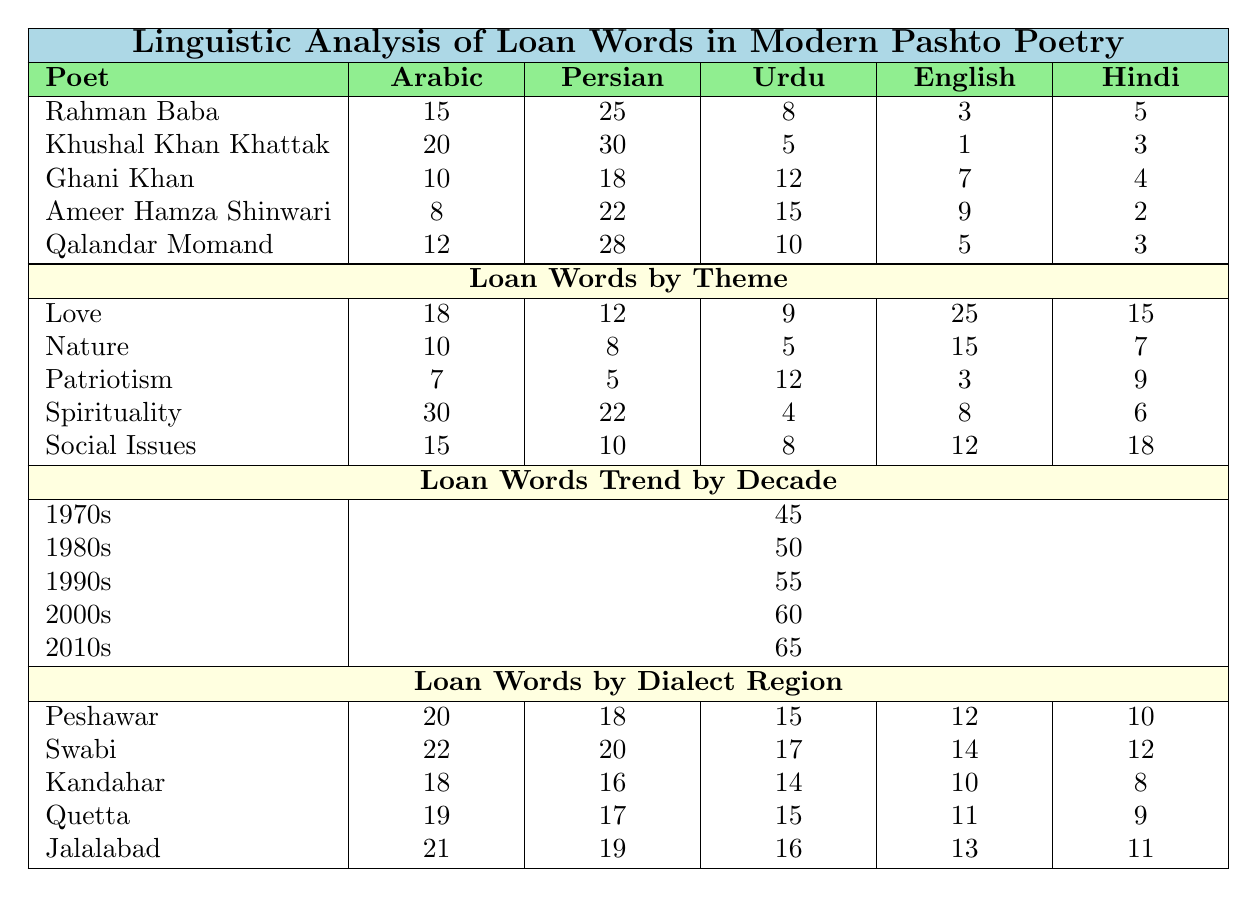What is the total number of loan words used by Ghani Khan? To find the total number of loan words used by Ghani Khan, sum up the values in his row: 10 (Arabic) + 18 (Persian) + 12 (Urdu) + 7 (English) + 4 (Hindi) = 51.
Answer: 51 Which poet has the highest use of Persian loan words? Look at the Persian column and find the maximum value: Khushal Khan Khattak has 30 Persian loan words, which is the highest among all poets listed.
Answer: Khushal Khan Khattak What is the average number of English loan words used by all poets? First, sum the English values for each poet: 3 + 1 + 7 + 9 + 5 = 25. Then divide by the number of poets, which is 5: 25/5 = 5.
Answer: 5 Do all poets use more Arabic loan words than English loan words? Compare the values for Arabic and English loan words for each poet: Rahman Baba (15 vs 3), Khushal Khan Khattak (20 vs 1), Ghani Khan (10 vs 7), Ameer Hamza Shinwari (8 vs 9), and Qalandar Momand (12 vs 5). Ameer Hamza Shinwari is the only poet that uses more English loan words (9) than Arabic (8).
Answer: No In which decade did the use of loan words peak? Look at the "Loan Words Trend by Decade" section and find the maximum value: The highest value is 95 in the 2010s, indicating that loan word usage peaked in that decade.
Answer: 2010s Which poetry theme has the most loan words associated with it? Examine the "Loan Words by Theme" section and identify the theme with the highest value: Spirituality has 30 loan words, which is the most.
Answer: Spirituality What is the difference in the number of Urdu loan words used by Qalandar Momand and Ameer Hamza Shinwari? Find the Urdu loan words for both poets: Qalandar Momand has 10, and Ameer Hamza Shinwari has 15. Subtract Ameer Hamza Shinwari's from Qalandar Momand's: 10 - 15 = -5.
Answer: -5 How many loan words are associated with Nature across all poets? Sum the values for Nature from all poets: 12 + 8 + 5 + 15 + 10 = 50.
Answer: 50 Which dialect region has the least use of Hindi loan words? Analyze the "Loan Words by Dialect Region" for Hindi values: Peshawar (10), Swabi (12), Kandahar (8), Quetta (9), Jalalabad (11). Kandahar has the least with 8.
Answer: Kandahar Is the total number of loan words used by poets from Swabi greater than that of those from Peshawar? First, sum the loan words for Swabi: 22 (Arabic) + 20 (Persian) + 17 (Urdu) + 14 (English) + 12 (Hindi) = 85. Then sum for Peshawar: 20 + 18 + 15 + 12 + 10 = 75. Since 85 is greater than 75, the answer is yes.
Answer: Yes 